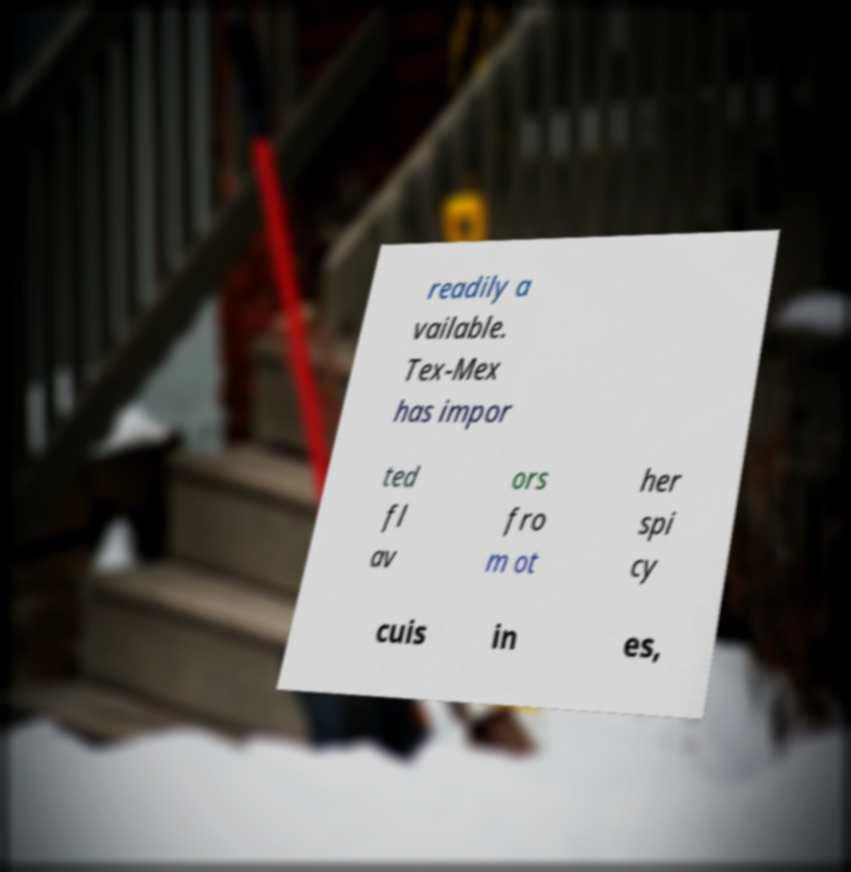I need the written content from this picture converted into text. Can you do that? readily a vailable. Tex-Mex has impor ted fl av ors fro m ot her spi cy cuis in es, 